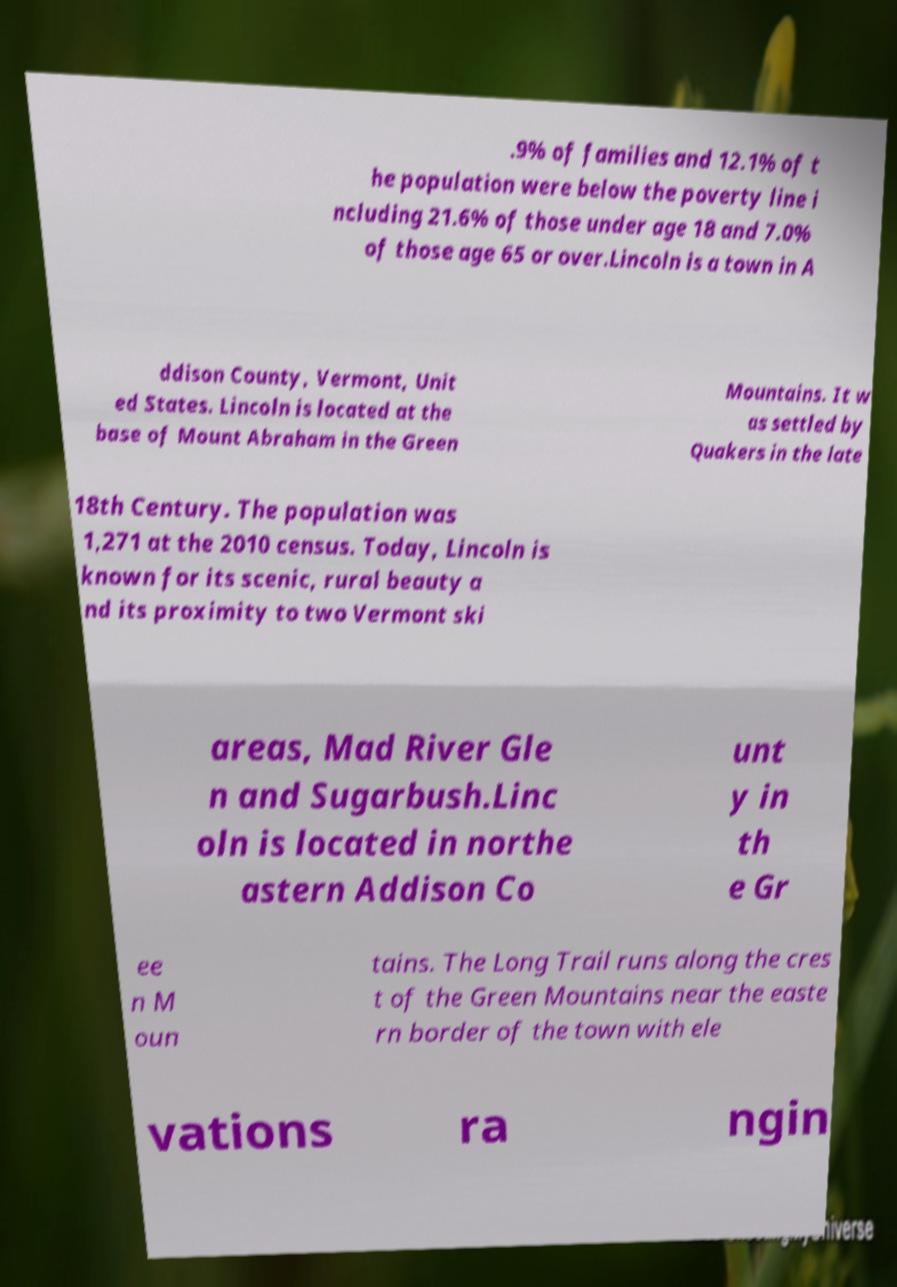Could you extract and type out the text from this image? .9% of families and 12.1% of t he population were below the poverty line i ncluding 21.6% of those under age 18 and 7.0% of those age 65 or over.Lincoln is a town in A ddison County, Vermont, Unit ed States. Lincoln is located at the base of Mount Abraham in the Green Mountains. It w as settled by Quakers in the late 18th Century. The population was 1,271 at the 2010 census. Today, Lincoln is known for its scenic, rural beauty a nd its proximity to two Vermont ski areas, Mad River Gle n and Sugarbush.Linc oln is located in northe astern Addison Co unt y in th e Gr ee n M oun tains. The Long Trail runs along the cres t of the Green Mountains near the easte rn border of the town with ele vations ra ngin 